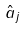Convert formula to latex. <formula><loc_0><loc_0><loc_500><loc_500>\hat { a } _ { j }</formula> 